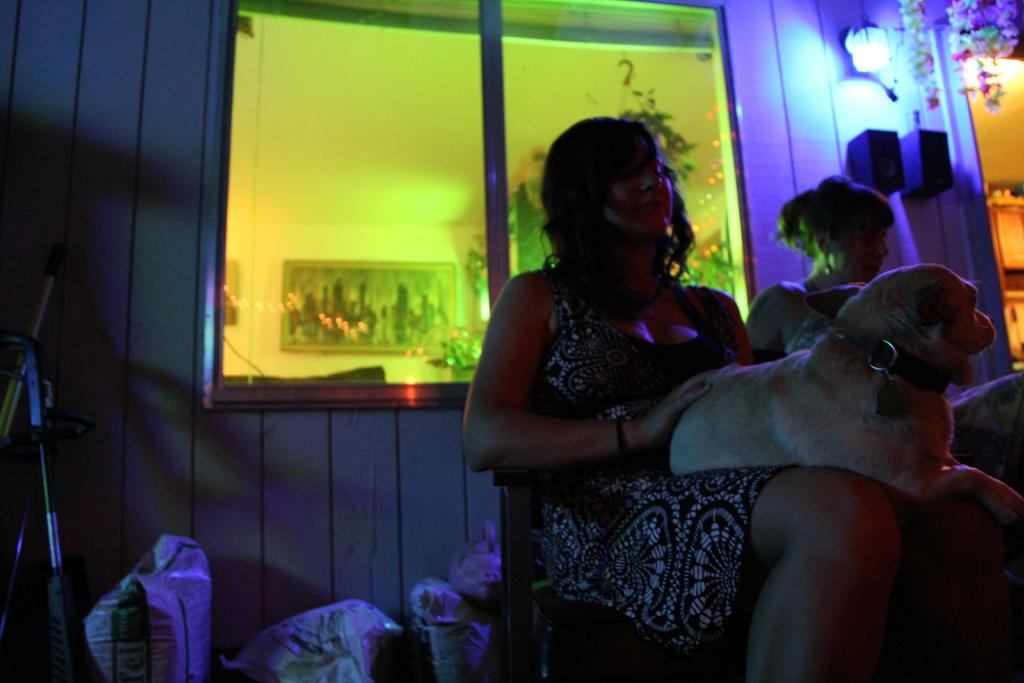How many people are in the image? There are two persons in the image. What else can be seen on the ground in the image? There are many objects on the ground in the image. What type of animal is present in the image? There is a dog in the image. Can you describe any decorative items in the image? There is a photo frame on the wall in the image. What type of lighting is present in the image? There are lamps in the image. What type of ring can be seen on the dog's nose in the image? There is no ring present on the dog's nose in the image; the dog does not have any visible accessories. 